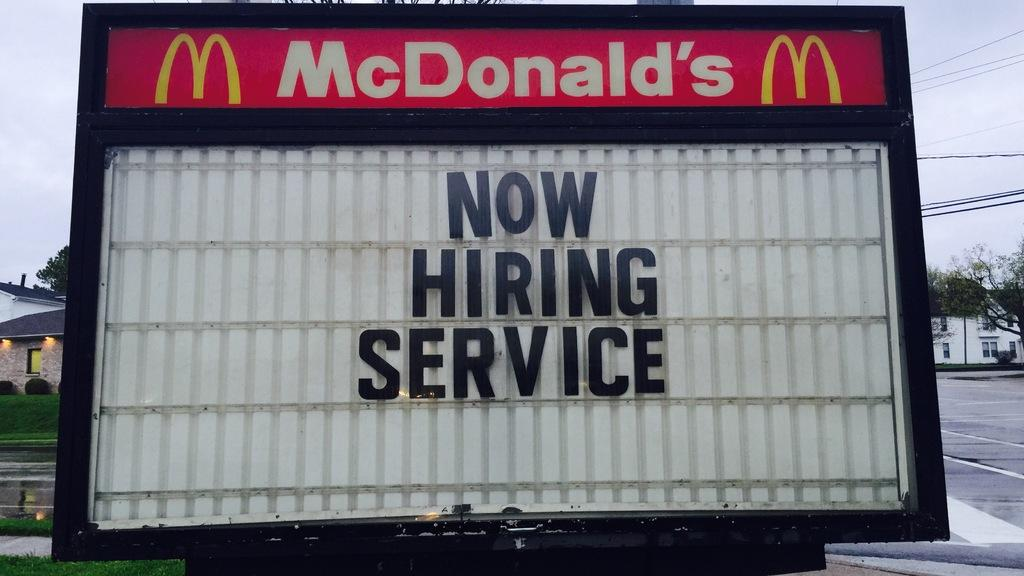<image>
Present a compact description of the photo's key features. A McDonald's sign that says "Now Hiring Service." 